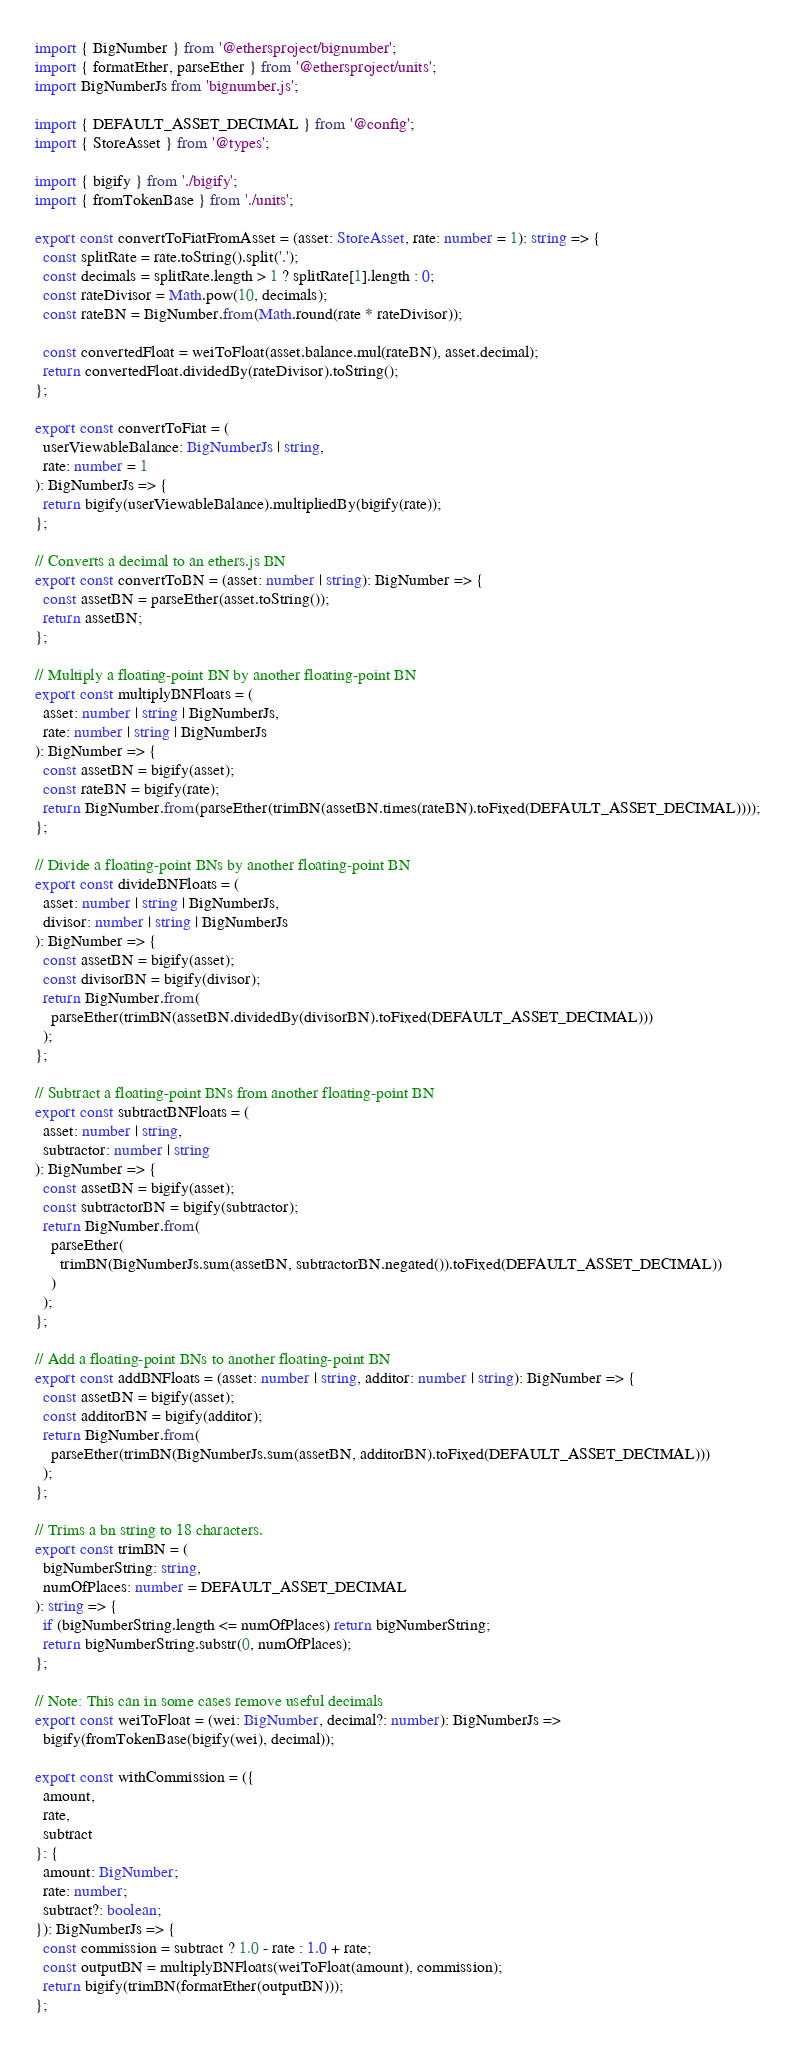Convert code to text. <code><loc_0><loc_0><loc_500><loc_500><_TypeScript_>import { BigNumber } from '@ethersproject/bignumber';
import { formatEther, parseEther } from '@ethersproject/units';
import BigNumberJs from 'bignumber.js';

import { DEFAULT_ASSET_DECIMAL } from '@config';
import { StoreAsset } from '@types';

import { bigify } from './bigify';
import { fromTokenBase } from './units';

export const convertToFiatFromAsset = (asset: StoreAsset, rate: number = 1): string => {
  const splitRate = rate.toString().split('.');
  const decimals = splitRate.length > 1 ? splitRate[1].length : 0;
  const rateDivisor = Math.pow(10, decimals);
  const rateBN = BigNumber.from(Math.round(rate * rateDivisor));

  const convertedFloat = weiToFloat(asset.balance.mul(rateBN), asset.decimal);
  return convertedFloat.dividedBy(rateDivisor).toString();
};

export const convertToFiat = (
  userViewableBalance: BigNumberJs | string,
  rate: number = 1
): BigNumberJs => {
  return bigify(userViewableBalance).multipliedBy(bigify(rate));
};

// Converts a decimal to an ethers.js BN
export const convertToBN = (asset: number | string): BigNumber => {
  const assetBN = parseEther(asset.toString());
  return assetBN;
};

// Multiply a floating-point BN by another floating-point BN
export const multiplyBNFloats = (
  asset: number | string | BigNumberJs,
  rate: number | string | BigNumberJs
): BigNumber => {
  const assetBN = bigify(asset);
  const rateBN = bigify(rate);
  return BigNumber.from(parseEther(trimBN(assetBN.times(rateBN).toFixed(DEFAULT_ASSET_DECIMAL))));
};

// Divide a floating-point BNs by another floating-point BN
export const divideBNFloats = (
  asset: number | string | BigNumberJs,
  divisor: number | string | BigNumberJs
): BigNumber => {
  const assetBN = bigify(asset);
  const divisorBN = bigify(divisor);
  return BigNumber.from(
    parseEther(trimBN(assetBN.dividedBy(divisorBN).toFixed(DEFAULT_ASSET_DECIMAL)))
  );
};

// Subtract a floating-point BNs from another floating-point BN
export const subtractBNFloats = (
  asset: number | string,
  subtractor: number | string
): BigNumber => {
  const assetBN = bigify(asset);
  const subtractorBN = bigify(subtractor);
  return BigNumber.from(
    parseEther(
      trimBN(BigNumberJs.sum(assetBN, subtractorBN.negated()).toFixed(DEFAULT_ASSET_DECIMAL))
    )
  );
};

// Add a floating-point BNs to another floating-point BN
export const addBNFloats = (asset: number | string, additor: number | string): BigNumber => {
  const assetBN = bigify(asset);
  const additorBN = bigify(additor);
  return BigNumber.from(
    parseEther(trimBN(BigNumberJs.sum(assetBN, additorBN).toFixed(DEFAULT_ASSET_DECIMAL)))
  );
};

// Trims a bn string to 18 characters.
export const trimBN = (
  bigNumberString: string,
  numOfPlaces: number = DEFAULT_ASSET_DECIMAL
): string => {
  if (bigNumberString.length <= numOfPlaces) return bigNumberString;
  return bigNumberString.substr(0, numOfPlaces);
};

// Note: This can in some cases remove useful decimals
export const weiToFloat = (wei: BigNumber, decimal?: number): BigNumberJs =>
  bigify(fromTokenBase(bigify(wei), decimal));

export const withCommission = ({
  amount,
  rate,
  subtract
}: {
  amount: BigNumber;
  rate: number;
  subtract?: boolean;
}): BigNumberJs => {
  const commission = subtract ? 1.0 - rate : 1.0 + rate;
  const outputBN = multiplyBNFloats(weiToFloat(amount), commission);
  return bigify(trimBN(formatEther(outputBN)));
};
</code> 